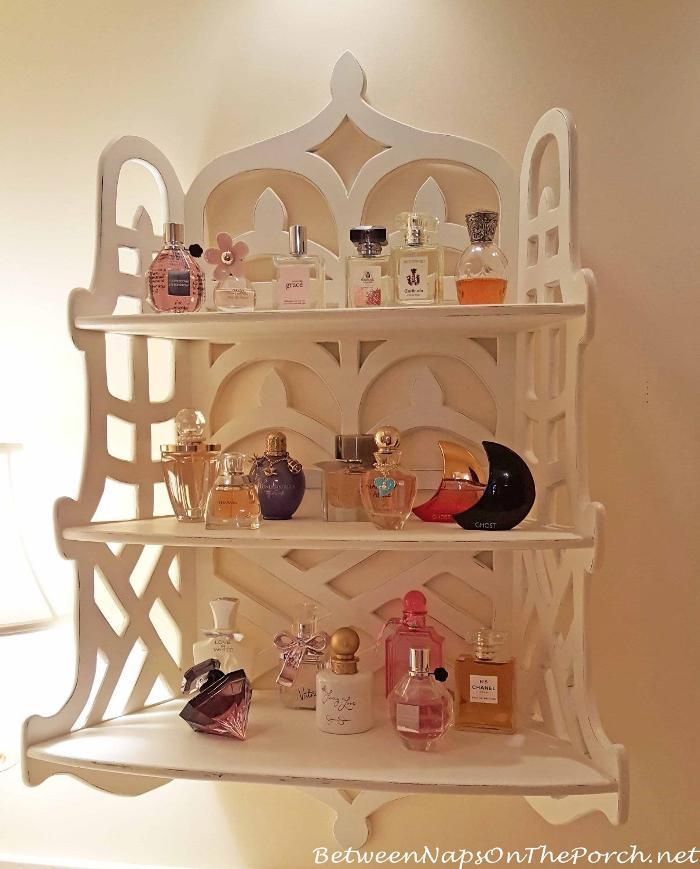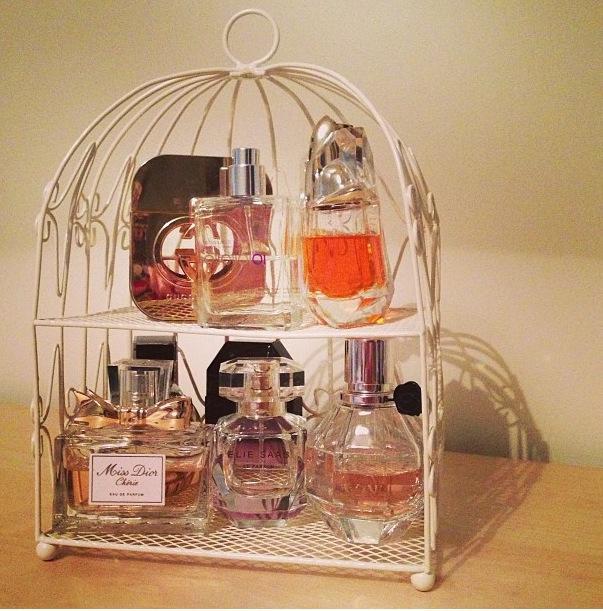The first image is the image on the left, the second image is the image on the right. For the images displayed, is the sentence "Each image features one display with multiple levels, and one image shows a white wall-mounted display with scrolling shapes on the top and bottom." factually correct? Answer yes or no. Yes. The first image is the image on the left, the second image is the image on the right. Considering the images on both sides, is "There are two tiers of shelves in the display in the image on the right." valid? Answer yes or no. Yes. 